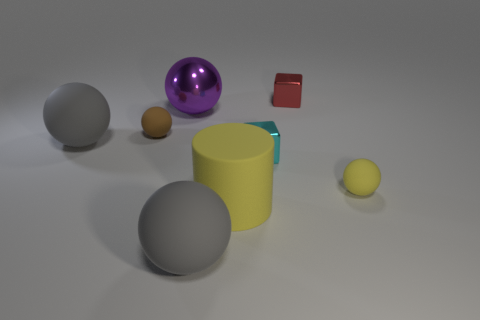Subtract all purple balls. How many balls are left? 4 Subtract all small brown matte balls. How many balls are left? 4 Subtract all green spheres. Subtract all purple cylinders. How many spheres are left? 5 Add 1 brown rubber objects. How many objects exist? 9 Subtract all cubes. How many objects are left? 6 Subtract all large cyan spheres. Subtract all large purple metal balls. How many objects are left? 7 Add 1 tiny objects. How many tiny objects are left? 5 Add 1 cyan matte blocks. How many cyan matte blocks exist? 1 Subtract 0 cyan cylinders. How many objects are left? 8 